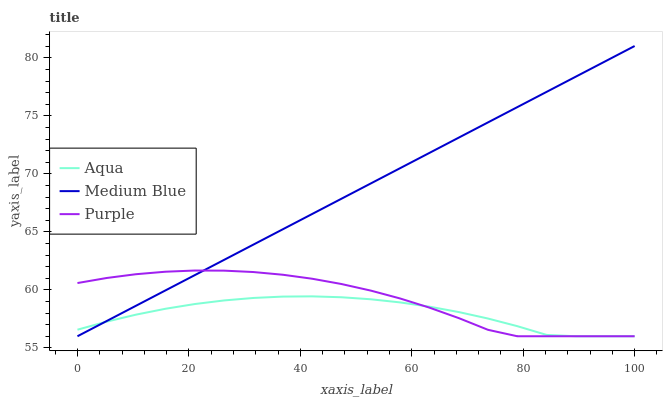Does Aqua have the minimum area under the curve?
Answer yes or no. Yes. Does Medium Blue have the maximum area under the curve?
Answer yes or no. Yes. Does Medium Blue have the minimum area under the curve?
Answer yes or no. No. Does Aqua have the maximum area under the curve?
Answer yes or no. No. Is Medium Blue the smoothest?
Answer yes or no. Yes. Is Purple the roughest?
Answer yes or no. Yes. Is Aqua the smoothest?
Answer yes or no. No. Is Aqua the roughest?
Answer yes or no. No. Does Purple have the lowest value?
Answer yes or no. Yes. Does Medium Blue have the highest value?
Answer yes or no. Yes. Does Aqua have the highest value?
Answer yes or no. No. Does Purple intersect Medium Blue?
Answer yes or no. Yes. Is Purple less than Medium Blue?
Answer yes or no. No. Is Purple greater than Medium Blue?
Answer yes or no. No. 